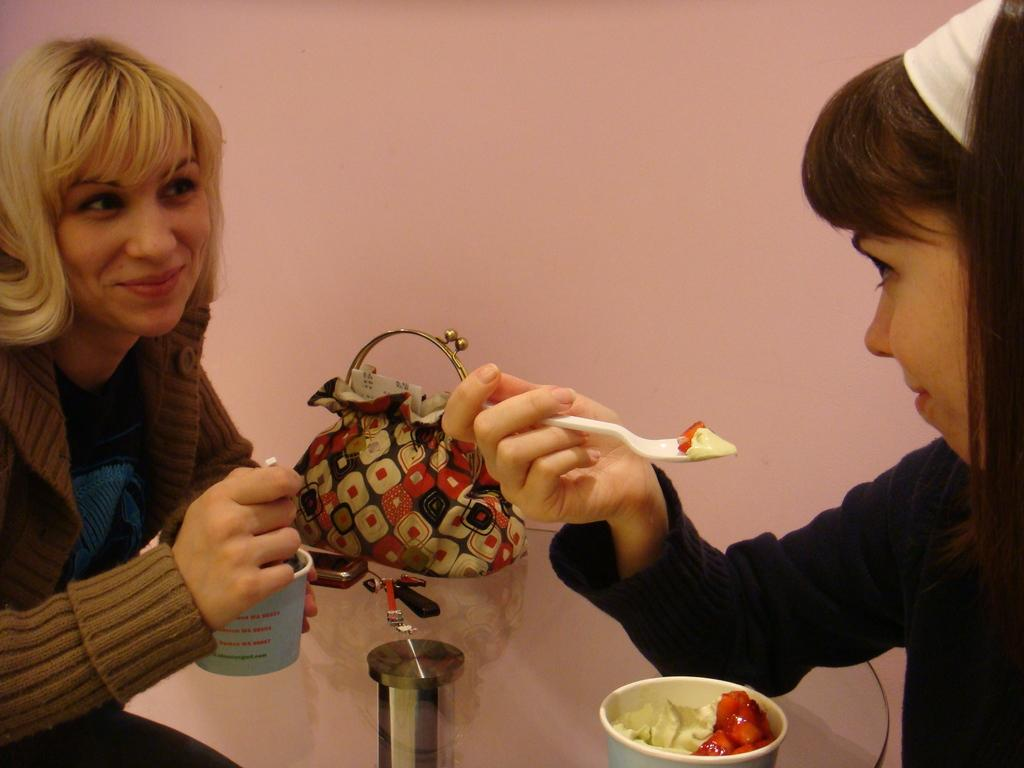Who is present in the image? There is a woman and a girl in the image. What is the woman holding in the image? The woman is holding a food cup in the image. What is the expression on the woman's face? The woman is smiling in the image. What is the girl holding in the image? The girl is holding a spoon in the image. What type of cap is the girl wearing in the image? There is no cap visible on the girl in the image. How many toes can be seen on the woman's foot in the image? There is no foot or toes visible in the image. --- Facts: 1. There is a car in the image. 2. The car is red. 3. The car has four wheels. 4. There is a road in the image. 5. The road is paved. Absurd Topics: bird, ocean, mountain Conversation: What is the main subject of the image? The main subject of the image is a car. What color is the car? The car is red. How many wheels does the car have? The car has four wheels. What type of surface is the car on? The car is on a road. What is the condition of the road in the image? The road is paved. Reasoning: Let's think step by step in order to produce the conversation. We start by identifying the main subject of the image, which is the car. Then, we describe the car's color and the number of wheels it has. Next, we mention the surface the car is on, which is a road. Finally, we describe the condition of the road, which is paved. Each question is designed to elicit a specific detail about the image that is known from the provided facts. Absurd Question/Answer: Can you see any birds flying over the ocean in the image? There is no ocean or birds visible in the image; it features a red car on a paved road. What type of mountain range can be seen in the background of the image? There is no mountain range visible in the image; it features a red car on a paved road. 